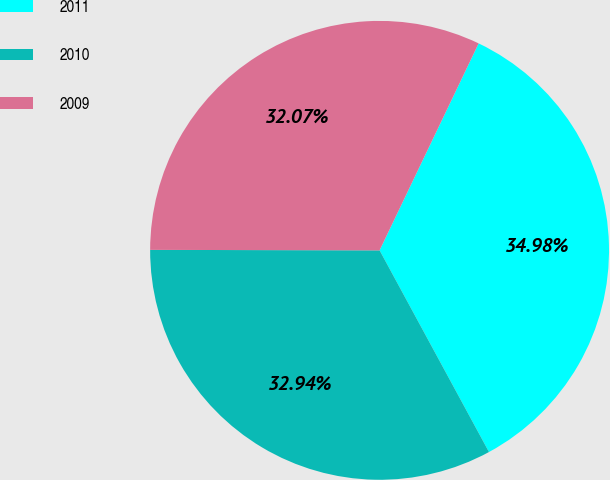Convert chart. <chart><loc_0><loc_0><loc_500><loc_500><pie_chart><fcel>2011<fcel>2010<fcel>2009<nl><fcel>34.98%<fcel>32.94%<fcel>32.07%<nl></chart> 